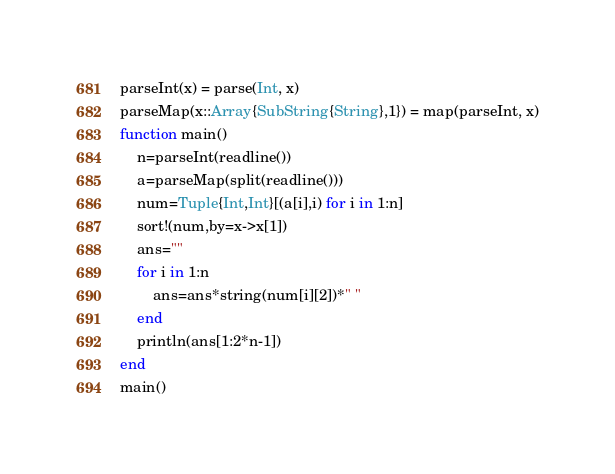<code> <loc_0><loc_0><loc_500><loc_500><_Julia_>parseInt(x) = parse(Int, x)
parseMap(x::Array{SubString{String},1}) = map(parseInt, x)
function main()
    n=parseInt(readline())
    a=parseMap(split(readline()))
    num=Tuple{Int,Int}[(a[i],i) for i in 1:n]
    sort!(num,by=x->x[1])
    ans=""
    for i in 1:n
        ans=ans*string(num[i][2])*" "
    end
    println(ans[1:2*n-1])
end
main()</code> 